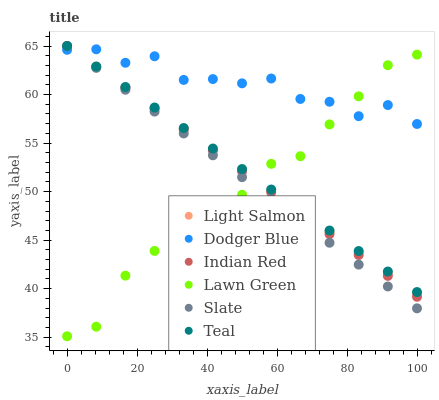Does Lawn Green have the minimum area under the curve?
Answer yes or no. Yes. Does Dodger Blue have the maximum area under the curve?
Answer yes or no. Yes. Does Light Salmon have the minimum area under the curve?
Answer yes or no. No. Does Light Salmon have the maximum area under the curve?
Answer yes or no. No. Is Teal the smoothest?
Answer yes or no. Yes. Is Lawn Green the roughest?
Answer yes or no. Yes. Is Light Salmon the smoothest?
Answer yes or no. No. Is Light Salmon the roughest?
Answer yes or no. No. Does Lawn Green have the lowest value?
Answer yes or no. Yes. Does Light Salmon have the lowest value?
Answer yes or no. No. Does Teal have the highest value?
Answer yes or no. Yes. Does Dodger Blue have the highest value?
Answer yes or no. No. Does Lawn Green intersect Light Salmon?
Answer yes or no. Yes. Is Lawn Green less than Light Salmon?
Answer yes or no. No. Is Lawn Green greater than Light Salmon?
Answer yes or no. No. 